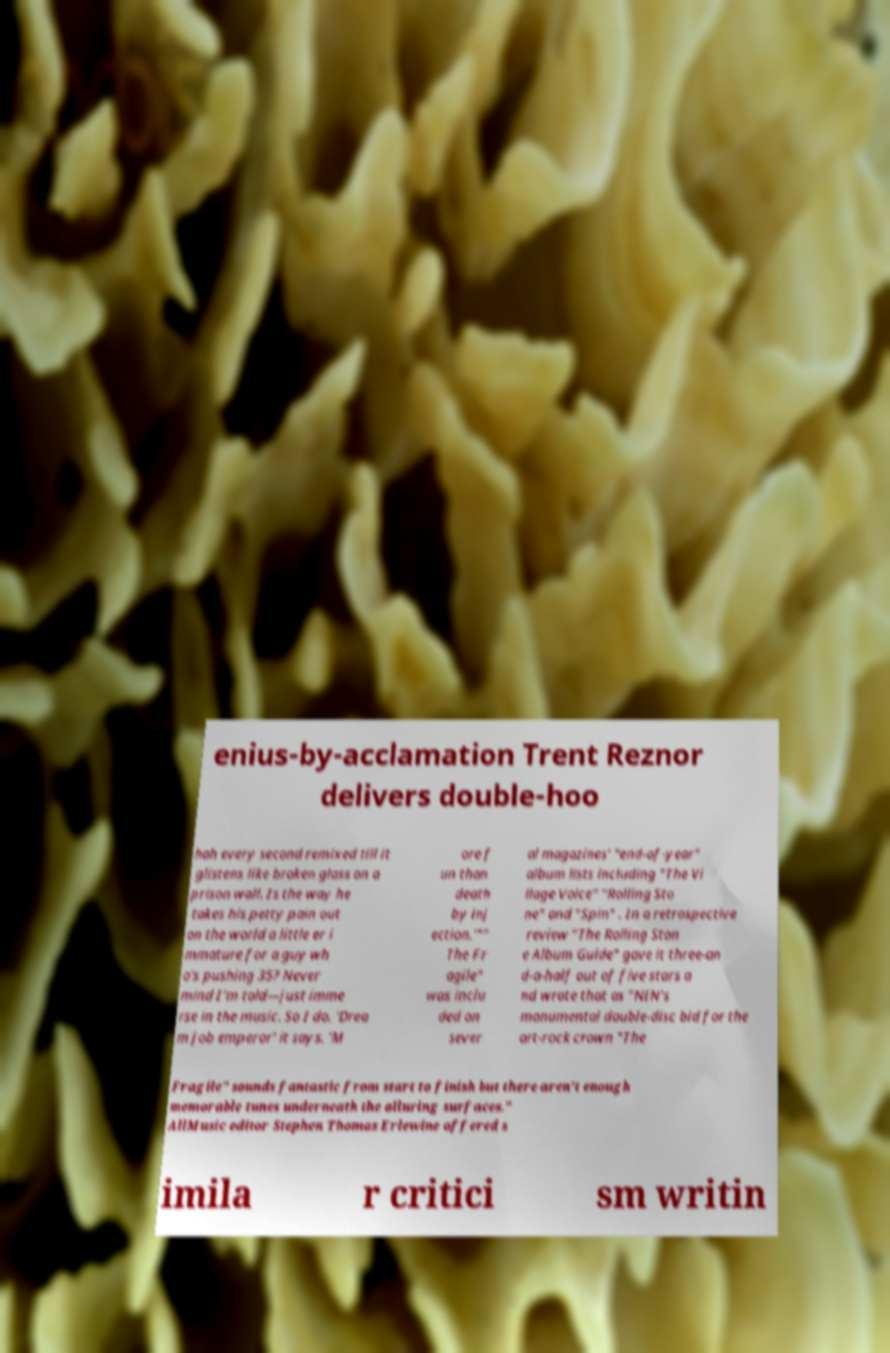For documentation purposes, I need the text within this image transcribed. Could you provide that? enius-by-acclamation Trent Reznor delivers double-hoo hah every second remixed till it glistens like broken glass on a prison wall. Is the way he takes his petty pain out on the world a little er i mmature for a guy wh o's pushing 35? Never mind I'm told—just imme rse in the music. So I do. 'Drea m job emperor' it says. 'M ore f un than death by inj ection.'"" The Fr agile" was inclu ded on sever al magazines' "end-of-year" album lists including "The Vi llage Voice" "Rolling Sto ne" and "Spin" . In a retrospective review "The Rolling Ston e Album Guide" gave it three-an d-a-half out of five stars a nd wrote that as "NIN's monumental double-disc bid for the art-rock crown "The Fragile" sounds fantastic from start to finish but there aren't enough memorable tunes underneath the alluring surfaces." AllMusic editor Stephen Thomas Erlewine offered s imila r critici sm writin 